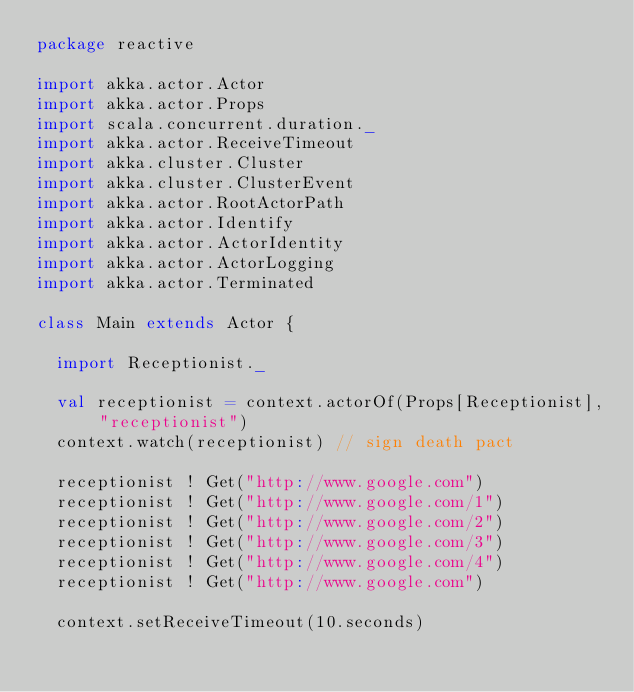<code> <loc_0><loc_0><loc_500><loc_500><_Scala_>package reactive

import akka.actor.Actor
import akka.actor.Props
import scala.concurrent.duration._
import akka.actor.ReceiveTimeout
import akka.cluster.Cluster
import akka.cluster.ClusterEvent
import akka.actor.RootActorPath
import akka.actor.Identify
import akka.actor.ActorIdentity
import akka.actor.ActorLogging
import akka.actor.Terminated

class Main extends Actor {

  import Receptionist._

  val receptionist = context.actorOf(Props[Receptionist], "receptionist")
  context.watch(receptionist) // sign death pact
  
  receptionist ! Get("http://www.google.com")
  receptionist ! Get("http://www.google.com/1")
  receptionist ! Get("http://www.google.com/2")
  receptionist ! Get("http://www.google.com/3")
  receptionist ! Get("http://www.google.com/4")
  receptionist ! Get("http://www.google.com")

  context.setReceiveTimeout(10.seconds)
</code> 